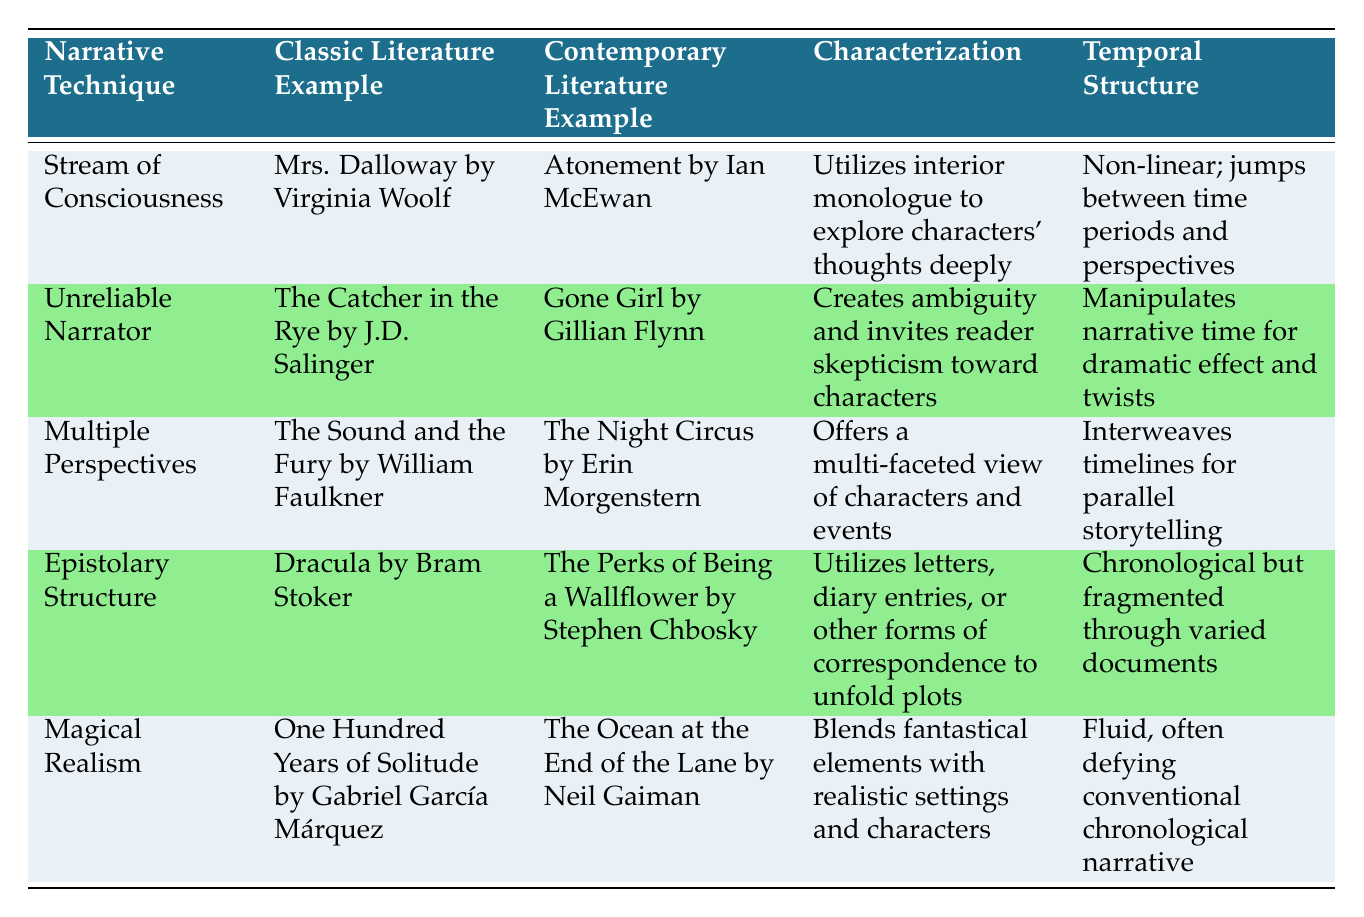What is the example of classic literature for the narrative technique "Stream of Consciousness"? The table lists "Mrs. Dalloway by Virginia Woolf" as the classic literature example under the "Stream of Consciousness" narrative technique.
Answer: Mrs. Dalloway by Virginia Woolf Which contemporary literature uses the "Unreliable Narrator" technique? According to the table, "Gone Girl by Gillian Flynn" is cited as the contemporary literature example for the "Unreliable Narrator" technique.
Answer: Gone Girl by Gillian Flynn Is "The Sound and the Fury" associated with the narrative technique "Multiple Perspectives"? The table clearly shows that "The Sound and the Fury by William Faulkner" is indeed associated with the "Multiple Perspectives" narrative technique.
Answer: Yes How many examples of classic literature use epistolary structure? The table lists only one classic literature example for the epistolary structure, which is "Dracula by Bram Stoker". Therefore, the count is 1.
Answer: 1 Which narrative technique combines fantastical elements with realistic settings? The "Magical Realism" narrative technique, as per the table, incorporates fantastical elements alongside realistic settings and is exemplified by "One Hundred Years of Solitude".
Answer: Magical Realism What is the characterization description for contemporary literature example "The Night Circus"? The table describes the characterization for "The Night Circus by Erin Morgenstern" under "Multiple Perspectives" as offering a multi-faceted view of characters and events.
Answer: Offers a multi-faceted view of characters and events Which classic literature example aligns with the "Stream of Consciousness" technique? The classic literature example associated with the "Stream of Consciousness" technique, as per the table, is "Mrs. Dalloway by Virginia Woolf".
Answer: Mrs. Dalloway by Virginia Woolf How does the temporal structure of "Atonement" differ from that of "Dracula"? The temporal structure for "Atonement" is non-linear, jumping between periods and perspectives, while "Dracula" maintains a chronological but fragmented structure through various documents. Thus, they differ in their approach to time.
Answer: Non-linear vs. chronological but fragmented How many narrative techniques listed in the table involve manipulation of narrative time? Two narrative techniques in the table involve manipulation of narrative time: "Unreliable Narrator" (manipulates narrative time for dramatic effect) and "Stream of Consciousness" (non-linear, jumps between time periods). This totals to 2.
Answer: 2 